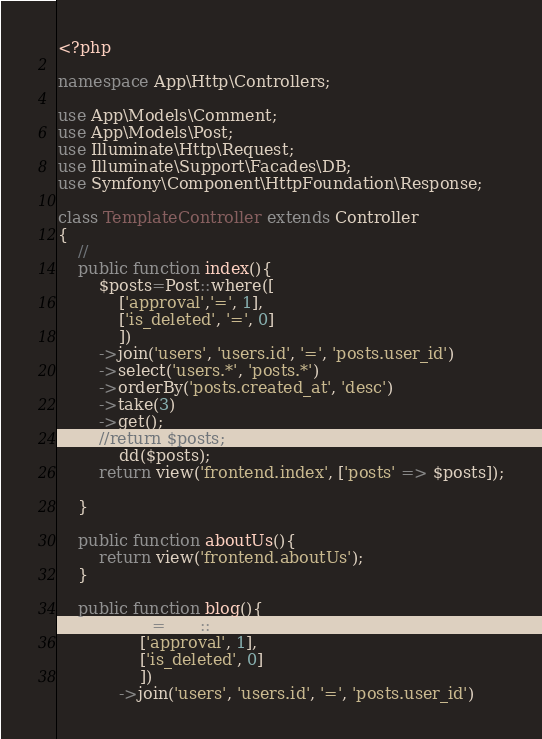<code> <loc_0><loc_0><loc_500><loc_500><_PHP_><?php

namespace App\Http\Controllers;

use App\Models\Comment;
use App\Models\Post;
use Illuminate\Http\Request;
use Illuminate\Support\Facades\DB;
use Symfony\Component\HttpFoundation\Response;

class TemplateController extends Controller
{
    //
    public function index(){
        $posts=Post::where([
            ['approval','=', 1],
            ['is_deleted', '=', 0]
            ])
        ->join('users', 'users.id', '=', 'posts.user_id')
        ->select('users.*', 'posts.*')
        ->orderBy('posts.created_at', 'desc')
        ->take(3)
        ->get();
        //return $posts;
            dd($posts);
        return view('frontend.index', ['posts' => $posts]);
        
    }

    public function aboutUs(){
        return view('frontend.aboutUs');
    }

    public function blog(){
        $posts=Post::where([
                ['approval', 1],
                ['is_deleted', 0]
                ])
            ->join('users', 'users.id', '=', 'posts.user_id')</code> 